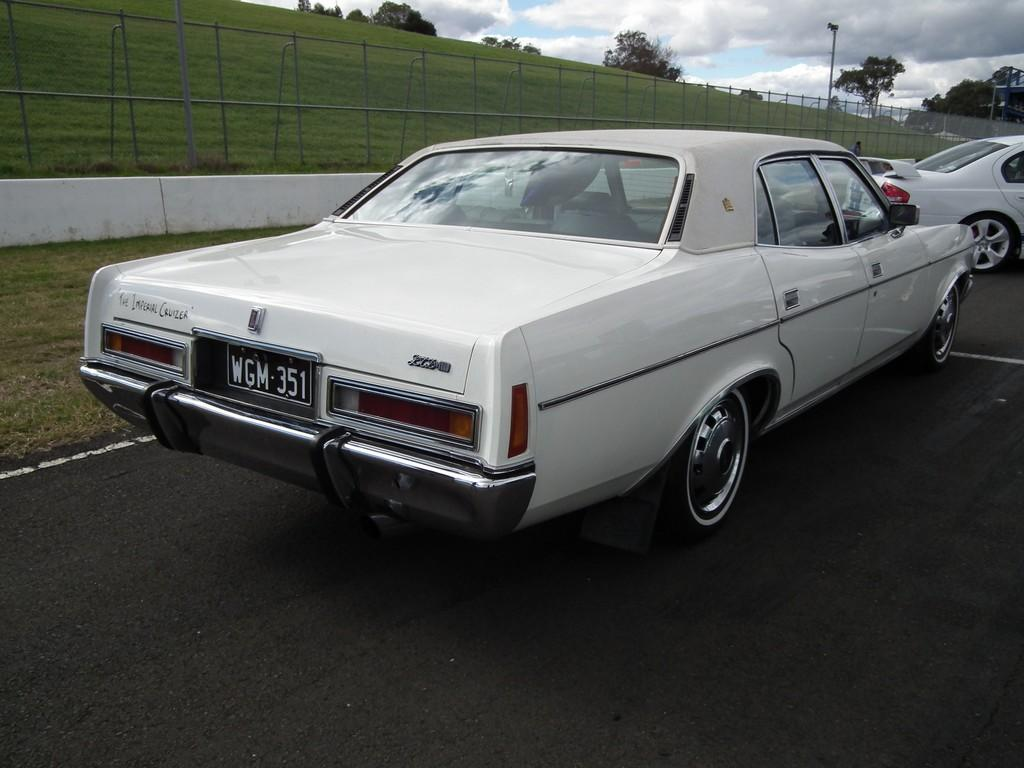What can be seen on the road in the image? There are vehicles on the road in the image. What is located next to the road? There is a railing visible next to the road, and grass is present next to the road. What other objects can be seen next to the road? There are poles visible next to the road. What is visible in the background of the image? There are many trees and clouds in the background of the image, and the sky is visible in the background. How many chairs are visible in the image? There are no chairs present in the image. Can you compare the size of the trees in the image to the size of the vehicles on the road? It is not possible to make a comparison between the size of the trees and the size of the vehicles in the image, as the provided facts do not include any information about the relative sizes of these objects. 